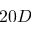<formula> <loc_0><loc_0><loc_500><loc_500>2 0 D</formula> 